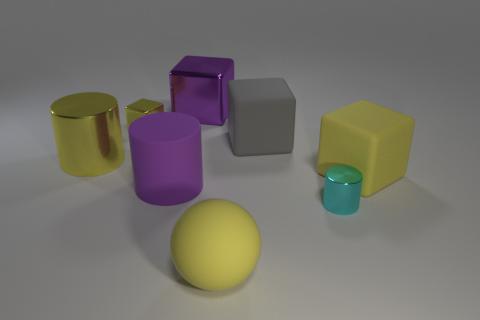Subtract 2 cubes. How many cubes are left? 2 Subtract all red cubes. Subtract all green cylinders. How many cubes are left? 4 Add 1 tiny cylinders. How many objects exist? 9 Subtract all spheres. How many objects are left? 7 Add 6 balls. How many balls exist? 7 Subtract 0 brown cubes. How many objects are left? 8 Subtract all large purple objects. Subtract all large yellow things. How many objects are left? 3 Add 1 yellow things. How many yellow things are left? 5 